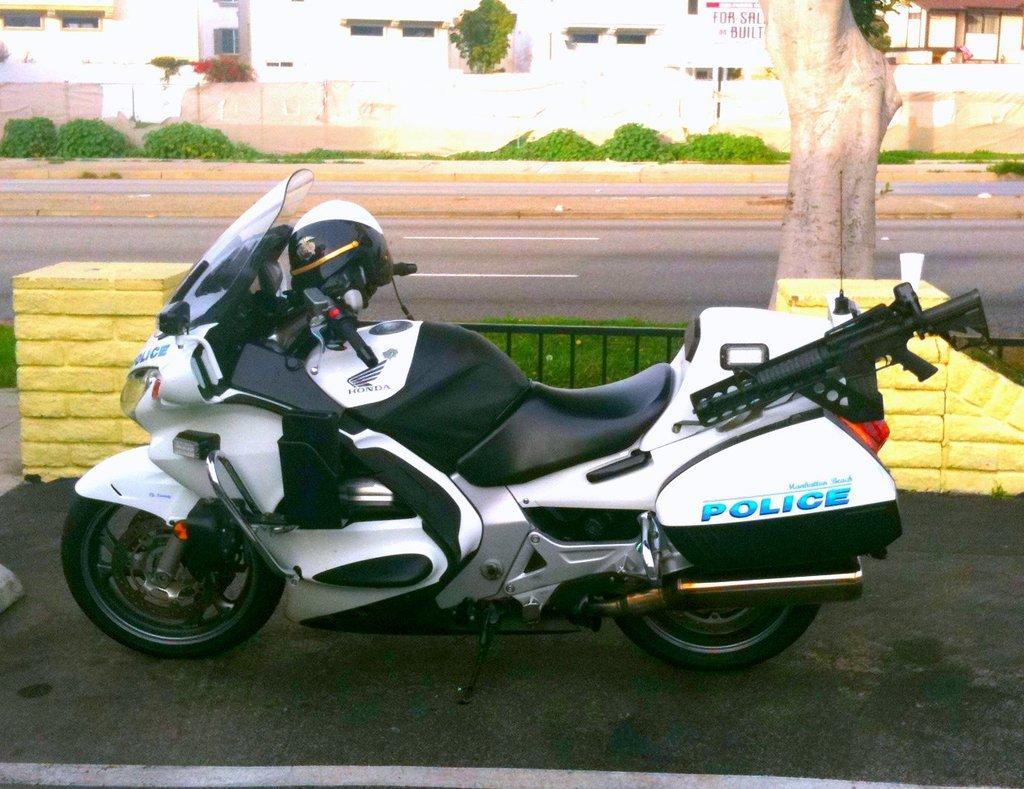How would you summarize this image in a sentence or two? In this image there is a bike on a road, behind the bike there is a railing, tree and a road, in the background there are plants and building. 